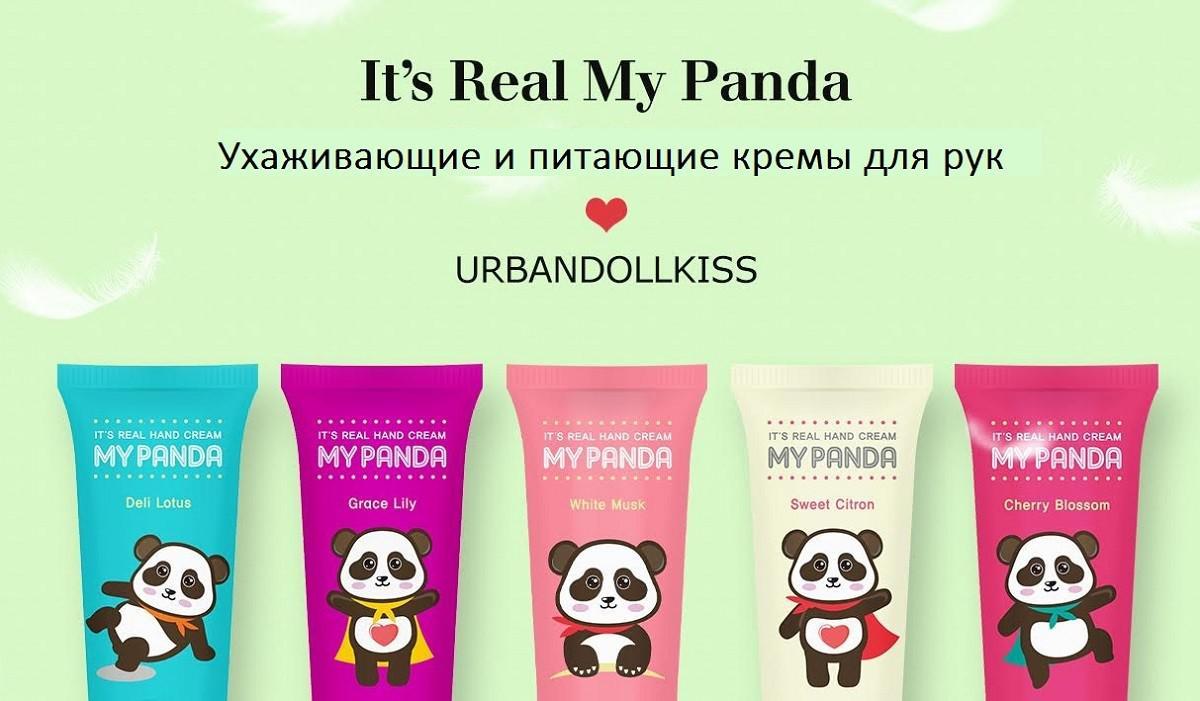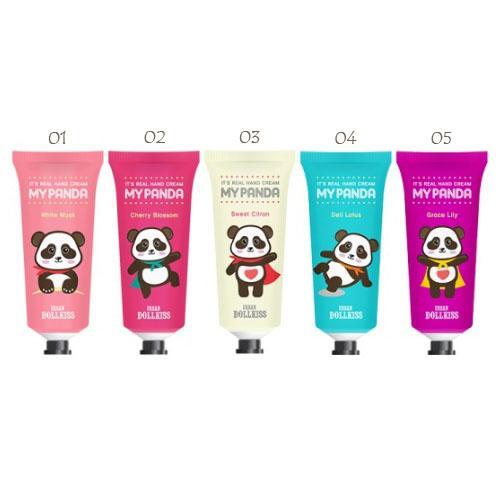The first image is the image on the left, the second image is the image on the right. Given the left and right images, does the statement "Each image shows five tubes, each a different color and with assorted cartoon pandas on their fronts." hold true? Answer yes or no. Yes. The first image is the image on the left, the second image is the image on the right. For the images displayed, is the sentence "There are pink, red, and white bottles next to each other in that order, and also blue and purple in that order." factually correct? Answer yes or no. Yes. 